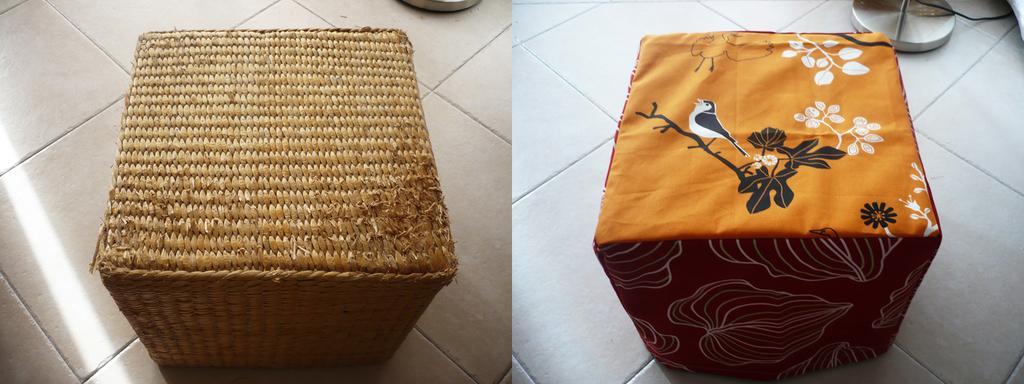Describe this image in one or two sentences. In this picture there is a collage photographs of the two table made of wooden. On the right side there is a table with yellow cover on it. Behind we can see a white flooring tiles. 